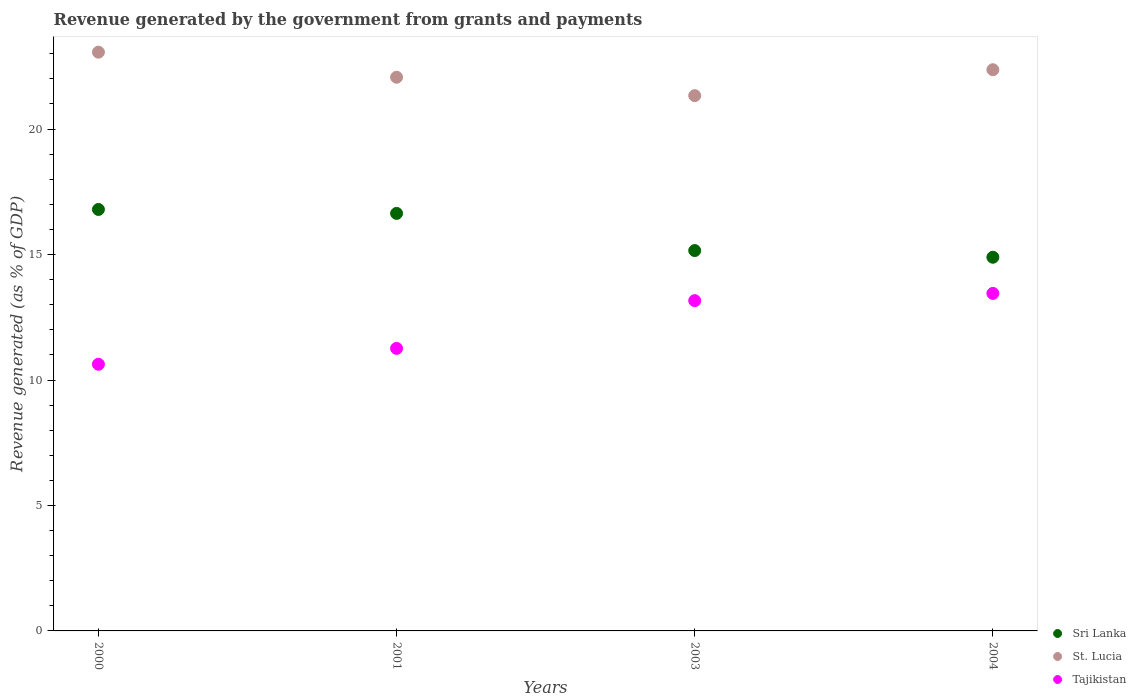What is the revenue generated by the government in Sri Lanka in 2001?
Make the answer very short. 16.64. Across all years, what is the maximum revenue generated by the government in St. Lucia?
Your response must be concise. 23.06. Across all years, what is the minimum revenue generated by the government in Tajikistan?
Your response must be concise. 10.63. In which year was the revenue generated by the government in Sri Lanka minimum?
Your answer should be very brief. 2004. What is the total revenue generated by the government in Sri Lanka in the graph?
Provide a succinct answer. 63.49. What is the difference between the revenue generated by the government in Sri Lanka in 2001 and that in 2003?
Your answer should be very brief. 1.48. What is the difference between the revenue generated by the government in Tajikistan in 2004 and the revenue generated by the government in Sri Lanka in 2003?
Your answer should be very brief. -1.71. What is the average revenue generated by the government in Tajikistan per year?
Ensure brevity in your answer.  12.13. In the year 2001, what is the difference between the revenue generated by the government in Sri Lanka and revenue generated by the government in St. Lucia?
Offer a very short reply. -5.43. What is the ratio of the revenue generated by the government in Tajikistan in 2003 to that in 2004?
Provide a succinct answer. 0.98. What is the difference between the highest and the second highest revenue generated by the government in Sri Lanka?
Provide a succinct answer. 0.16. What is the difference between the highest and the lowest revenue generated by the government in Tajikistan?
Ensure brevity in your answer.  2.82. In how many years, is the revenue generated by the government in Tajikistan greater than the average revenue generated by the government in Tajikistan taken over all years?
Offer a terse response. 2. Is the sum of the revenue generated by the government in Tajikistan in 2000 and 2004 greater than the maximum revenue generated by the government in St. Lucia across all years?
Your response must be concise. Yes. Is it the case that in every year, the sum of the revenue generated by the government in Tajikistan and revenue generated by the government in St. Lucia  is greater than the revenue generated by the government in Sri Lanka?
Your answer should be very brief. Yes. Does the revenue generated by the government in Sri Lanka monotonically increase over the years?
Provide a short and direct response. No. Is the revenue generated by the government in Tajikistan strictly less than the revenue generated by the government in Sri Lanka over the years?
Keep it short and to the point. Yes. How many dotlines are there?
Provide a short and direct response. 3. How many years are there in the graph?
Your answer should be compact. 4. What is the difference between two consecutive major ticks on the Y-axis?
Provide a short and direct response. 5. Are the values on the major ticks of Y-axis written in scientific E-notation?
Your answer should be compact. No. Does the graph contain grids?
Give a very brief answer. No. How are the legend labels stacked?
Ensure brevity in your answer.  Vertical. What is the title of the graph?
Provide a short and direct response. Revenue generated by the government from grants and payments. Does "Cabo Verde" appear as one of the legend labels in the graph?
Offer a very short reply. No. What is the label or title of the Y-axis?
Offer a very short reply. Revenue generated (as % of GDP). What is the Revenue generated (as % of GDP) of Sri Lanka in 2000?
Give a very brief answer. 16.8. What is the Revenue generated (as % of GDP) of St. Lucia in 2000?
Your response must be concise. 23.06. What is the Revenue generated (as % of GDP) of Tajikistan in 2000?
Your answer should be very brief. 10.63. What is the Revenue generated (as % of GDP) of Sri Lanka in 2001?
Keep it short and to the point. 16.64. What is the Revenue generated (as % of GDP) of St. Lucia in 2001?
Provide a succinct answer. 22.07. What is the Revenue generated (as % of GDP) in Tajikistan in 2001?
Provide a succinct answer. 11.26. What is the Revenue generated (as % of GDP) of Sri Lanka in 2003?
Provide a succinct answer. 15.16. What is the Revenue generated (as % of GDP) in St. Lucia in 2003?
Provide a short and direct response. 21.33. What is the Revenue generated (as % of GDP) of Tajikistan in 2003?
Keep it short and to the point. 13.16. What is the Revenue generated (as % of GDP) in Sri Lanka in 2004?
Keep it short and to the point. 14.89. What is the Revenue generated (as % of GDP) in St. Lucia in 2004?
Provide a short and direct response. 22.37. What is the Revenue generated (as % of GDP) of Tajikistan in 2004?
Offer a very short reply. 13.45. Across all years, what is the maximum Revenue generated (as % of GDP) of Sri Lanka?
Keep it short and to the point. 16.8. Across all years, what is the maximum Revenue generated (as % of GDP) of St. Lucia?
Your answer should be compact. 23.06. Across all years, what is the maximum Revenue generated (as % of GDP) in Tajikistan?
Provide a short and direct response. 13.45. Across all years, what is the minimum Revenue generated (as % of GDP) in Sri Lanka?
Your response must be concise. 14.89. Across all years, what is the minimum Revenue generated (as % of GDP) of St. Lucia?
Provide a short and direct response. 21.33. Across all years, what is the minimum Revenue generated (as % of GDP) in Tajikistan?
Provide a short and direct response. 10.63. What is the total Revenue generated (as % of GDP) of Sri Lanka in the graph?
Offer a very short reply. 63.49. What is the total Revenue generated (as % of GDP) in St. Lucia in the graph?
Keep it short and to the point. 88.83. What is the total Revenue generated (as % of GDP) in Tajikistan in the graph?
Your answer should be compact. 48.5. What is the difference between the Revenue generated (as % of GDP) of Sri Lanka in 2000 and that in 2001?
Make the answer very short. 0.16. What is the difference between the Revenue generated (as % of GDP) in St. Lucia in 2000 and that in 2001?
Keep it short and to the point. 1. What is the difference between the Revenue generated (as % of GDP) of Tajikistan in 2000 and that in 2001?
Give a very brief answer. -0.63. What is the difference between the Revenue generated (as % of GDP) of Sri Lanka in 2000 and that in 2003?
Provide a short and direct response. 1.64. What is the difference between the Revenue generated (as % of GDP) in St. Lucia in 2000 and that in 2003?
Ensure brevity in your answer.  1.73. What is the difference between the Revenue generated (as % of GDP) in Tajikistan in 2000 and that in 2003?
Ensure brevity in your answer.  -2.54. What is the difference between the Revenue generated (as % of GDP) in Sri Lanka in 2000 and that in 2004?
Offer a terse response. 1.91. What is the difference between the Revenue generated (as % of GDP) in St. Lucia in 2000 and that in 2004?
Provide a short and direct response. 0.7. What is the difference between the Revenue generated (as % of GDP) in Tajikistan in 2000 and that in 2004?
Offer a very short reply. -2.82. What is the difference between the Revenue generated (as % of GDP) of Sri Lanka in 2001 and that in 2003?
Your answer should be compact. 1.48. What is the difference between the Revenue generated (as % of GDP) of St. Lucia in 2001 and that in 2003?
Provide a succinct answer. 0.73. What is the difference between the Revenue generated (as % of GDP) of Tajikistan in 2001 and that in 2003?
Offer a very short reply. -1.9. What is the difference between the Revenue generated (as % of GDP) of Sri Lanka in 2001 and that in 2004?
Your answer should be compact. 1.75. What is the difference between the Revenue generated (as % of GDP) in St. Lucia in 2001 and that in 2004?
Your response must be concise. -0.3. What is the difference between the Revenue generated (as % of GDP) in Tajikistan in 2001 and that in 2004?
Make the answer very short. -2.19. What is the difference between the Revenue generated (as % of GDP) of Sri Lanka in 2003 and that in 2004?
Keep it short and to the point. 0.27. What is the difference between the Revenue generated (as % of GDP) in St. Lucia in 2003 and that in 2004?
Ensure brevity in your answer.  -1.03. What is the difference between the Revenue generated (as % of GDP) of Tajikistan in 2003 and that in 2004?
Provide a succinct answer. -0.29. What is the difference between the Revenue generated (as % of GDP) of Sri Lanka in 2000 and the Revenue generated (as % of GDP) of St. Lucia in 2001?
Your answer should be very brief. -5.27. What is the difference between the Revenue generated (as % of GDP) of Sri Lanka in 2000 and the Revenue generated (as % of GDP) of Tajikistan in 2001?
Offer a very short reply. 5.54. What is the difference between the Revenue generated (as % of GDP) of St. Lucia in 2000 and the Revenue generated (as % of GDP) of Tajikistan in 2001?
Your answer should be compact. 11.81. What is the difference between the Revenue generated (as % of GDP) in Sri Lanka in 2000 and the Revenue generated (as % of GDP) in St. Lucia in 2003?
Give a very brief answer. -4.54. What is the difference between the Revenue generated (as % of GDP) of Sri Lanka in 2000 and the Revenue generated (as % of GDP) of Tajikistan in 2003?
Offer a very short reply. 3.63. What is the difference between the Revenue generated (as % of GDP) in St. Lucia in 2000 and the Revenue generated (as % of GDP) in Tajikistan in 2003?
Your answer should be compact. 9.9. What is the difference between the Revenue generated (as % of GDP) in Sri Lanka in 2000 and the Revenue generated (as % of GDP) in St. Lucia in 2004?
Your answer should be compact. -5.57. What is the difference between the Revenue generated (as % of GDP) in Sri Lanka in 2000 and the Revenue generated (as % of GDP) in Tajikistan in 2004?
Give a very brief answer. 3.35. What is the difference between the Revenue generated (as % of GDP) of St. Lucia in 2000 and the Revenue generated (as % of GDP) of Tajikistan in 2004?
Offer a terse response. 9.61. What is the difference between the Revenue generated (as % of GDP) in Sri Lanka in 2001 and the Revenue generated (as % of GDP) in St. Lucia in 2003?
Provide a short and direct response. -4.69. What is the difference between the Revenue generated (as % of GDP) in Sri Lanka in 2001 and the Revenue generated (as % of GDP) in Tajikistan in 2003?
Give a very brief answer. 3.48. What is the difference between the Revenue generated (as % of GDP) of St. Lucia in 2001 and the Revenue generated (as % of GDP) of Tajikistan in 2003?
Keep it short and to the point. 8.9. What is the difference between the Revenue generated (as % of GDP) in Sri Lanka in 2001 and the Revenue generated (as % of GDP) in St. Lucia in 2004?
Give a very brief answer. -5.73. What is the difference between the Revenue generated (as % of GDP) of Sri Lanka in 2001 and the Revenue generated (as % of GDP) of Tajikistan in 2004?
Provide a short and direct response. 3.19. What is the difference between the Revenue generated (as % of GDP) in St. Lucia in 2001 and the Revenue generated (as % of GDP) in Tajikistan in 2004?
Your response must be concise. 8.61. What is the difference between the Revenue generated (as % of GDP) in Sri Lanka in 2003 and the Revenue generated (as % of GDP) in St. Lucia in 2004?
Ensure brevity in your answer.  -7.21. What is the difference between the Revenue generated (as % of GDP) of Sri Lanka in 2003 and the Revenue generated (as % of GDP) of Tajikistan in 2004?
Your response must be concise. 1.71. What is the difference between the Revenue generated (as % of GDP) of St. Lucia in 2003 and the Revenue generated (as % of GDP) of Tajikistan in 2004?
Offer a very short reply. 7.88. What is the average Revenue generated (as % of GDP) of Sri Lanka per year?
Make the answer very short. 15.87. What is the average Revenue generated (as % of GDP) of St. Lucia per year?
Your response must be concise. 22.21. What is the average Revenue generated (as % of GDP) of Tajikistan per year?
Keep it short and to the point. 12.13. In the year 2000, what is the difference between the Revenue generated (as % of GDP) of Sri Lanka and Revenue generated (as % of GDP) of St. Lucia?
Provide a short and direct response. -6.27. In the year 2000, what is the difference between the Revenue generated (as % of GDP) of Sri Lanka and Revenue generated (as % of GDP) of Tajikistan?
Keep it short and to the point. 6.17. In the year 2000, what is the difference between the Revenue generated (as % of GDP) in St. Lucia and Revenue generated (as % of GDP) in Tajikistan?
Give a very brief answer. 12.44. In the year 2001, what is the difference between the Revenue generated (as % of GDP) of Sri Lanka and Revenue generated (as % of GDP) of St. Lucia?
Your answer should be very brief. -5.43. In the year 2001, what is the difference between the Revenue generated (as % of GDP) of Sri Lanka and Revenue generated (as % of GDP) of Tajikistan?
Ensure brevity in your answer.  5.38. In the year 2001, what is the difference between the Revenue generated (as % of GDP) of St. Lucia and Revenue generated (as % of GDP) of Tajikistan?
Your answer should be very brief. 10.81. In the year 2003, what is the difference between the Revenue generated (as % of GDP) in Sri Lanka and Revenue generated (as % of GDP) in St. Lucia?
Keep it short and to the point. -6.17. In the year 2003, what is the difference between the Revenue generated (as % of GDP) in Sri Lanka and Revenue generated (as % of GDP) in Tajikistan?
Offer a very short reply. 2. In the year 2003, what is the difference between the Revenue generated (as % of GDP) of St. Lucia and Revenue generated (as % of GDP) of Tajikistan?
Keep it short and to the point. 8.17. In the year 2004, what is the difference between the Revenue generated (as % of GDP) of Sri Lanka and Revenue generated (as % of GDP) of St. Lucia?
Keep it short and to the point. -7.47. In the year 2004, what is the difference between the Revenue generated (as % of GDP) of Sri Lanka and Revenue generated (as % of GDP) of Tajikistan?
Make the answer very short. 1.44. In the year 2004, what is the difference between the Revenue generated (as % of GDP) in St. Lucia and Revenue generated (as % of GDP) in Tajikistan?
Ensure brevity in your answer.  8.91. What is the ratio of the Revenue generated (as % of GDP) of Sri Lanka in 2000 to that in 2001?
Your answer should be very brief. 1.01. What is the ratio of the Revenue generated (as % of GDP) in St. Lucia in 2000 to that in 2001?
Your answer should be compact. 1.05. What is the ratio of the Revenue generated (as % of GDP) in Tajikistan in 2000 to that in 2001?
Ensure brevity in your answer.  0.94. What is the ratio of the Revenue generated (as % of GDP) of Sri Lanka in 2000 to that in 2003?
Ensure brevity in your answer.  1.11. What is the ratio of the Revenue generated (as % of GDP) of St. Lucia in 2000 to that in 2003?
Offer a terse response. 1.08. What is the ratio of the Revenue generated (as % of GDP) of Tajikistan in 2000 to that in 2003?
Offer a very short reply. 0.81. What is the ratio of the Revenue generated (as % of GDP) of Sri Lanka in 2000 to that in 2004?
Offer a very short reply. 1.13. What is the ratio of the Revenue generated (as % of GDP) of St. Lucia in 2000 to that in 2004?
Provide a short and direct response. 1.03. What is the ratio of the Revenue generated (as % of GDP) of Tajikistan in 2000 to that in 2004?
Your response must be concise. 0.79. What is the ratio of the Revenue generated (as % of GDP) in Sri Lanka in 2001 to that in 2003?
Your response must be concise. 1.1. What is the ratio of the Revenue generated (as % of GDP) of St. Lucia in 2001 to that in 2003?
Give a very brief answer. 1.03. What is the ratio of the Revenue generated (as % of GDP) in Tajikistan in 2001 to that in 2003?
Your response must be concise. 0.86. What is the ratio of the Revenue generated (as % of GDP) of Sri Lanka in 2001 to that in 2004?
Keep it short and to the point. 1.12. What is the ratio of the Revenue generated (as % of GDP) in St. Lucia in 2001 to that in 2004?
Offer a terse response. 0.99. What is the ratio of the Revenue generated (as % of GDP) of Tajikistan in 2001 to that in 2004?
Your response must be concise. 0.84. What is the ratio of the Revenue generated (as % of GDP) in Sri Lanka in 2003 to that in 2004?
Make the answer very short. 1.02. What is the ratio of the Revenue generated (as % of GDP) of St. Lucia in 2003 to that in 2004?
Provide a succinct answer. 0.95. What is the ratio of the Revenue generated (as % of GDP) in Tajikistan in 2003 to that in 2004?
Give a very brief answer. 0.98. What is the difference between the highest and the second highest Revenue generated (as % of GDP) of Sri Lanka?
Offer a very short reply. 0.16. What is the difference between the highest and the second highest Revenue generated (as % of GDP) of St. Lucia?
Your answer should be compact. 0.7. What is the difference between the highest and the second highest Revenue generated (as % of GDP) in Tajikistan?
Your answer should be compact. 0.29. What is the difference between the highest and the lowest Revenue generated (as % of GDP) of Sri Lanka?
Give a very brief answer. 1.91. What is the difference between the highest and the lowest Revenue generated (as % of GDP) of St. Lucia?
Offer a terse response. 1.73. What is the difference between the highest and the lowest Revenue generated (as % of GDP) of Tajikistan?
Provide a short and direct response. 2.82. 